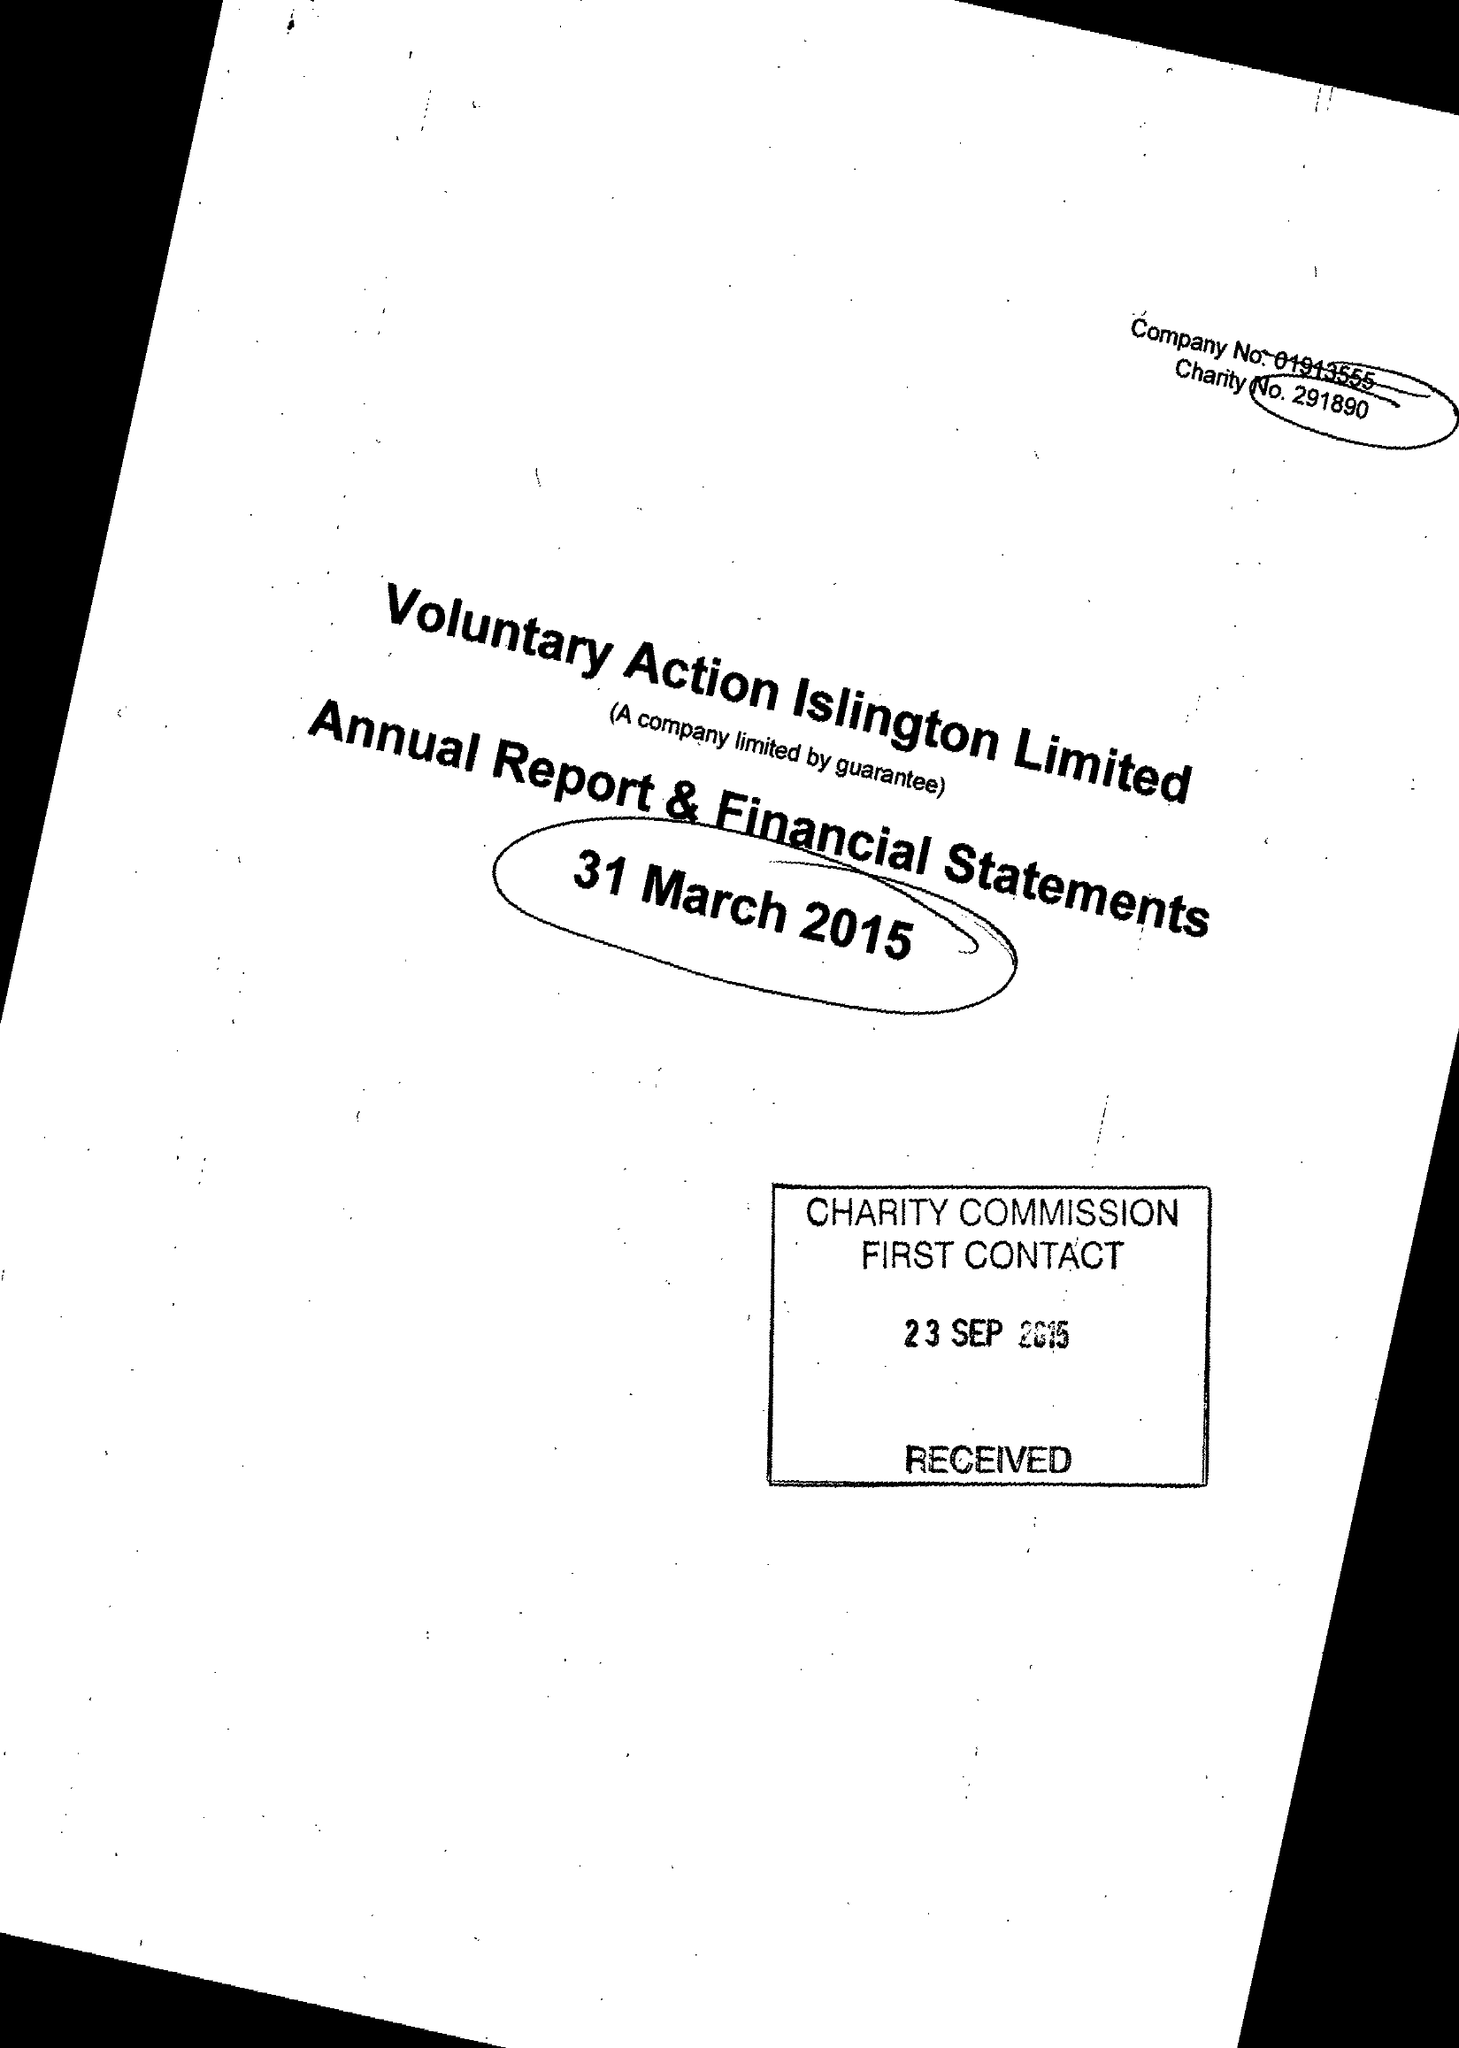What is the value for the address__post_town?
Answer the question using a single word or phrase. LONDON 